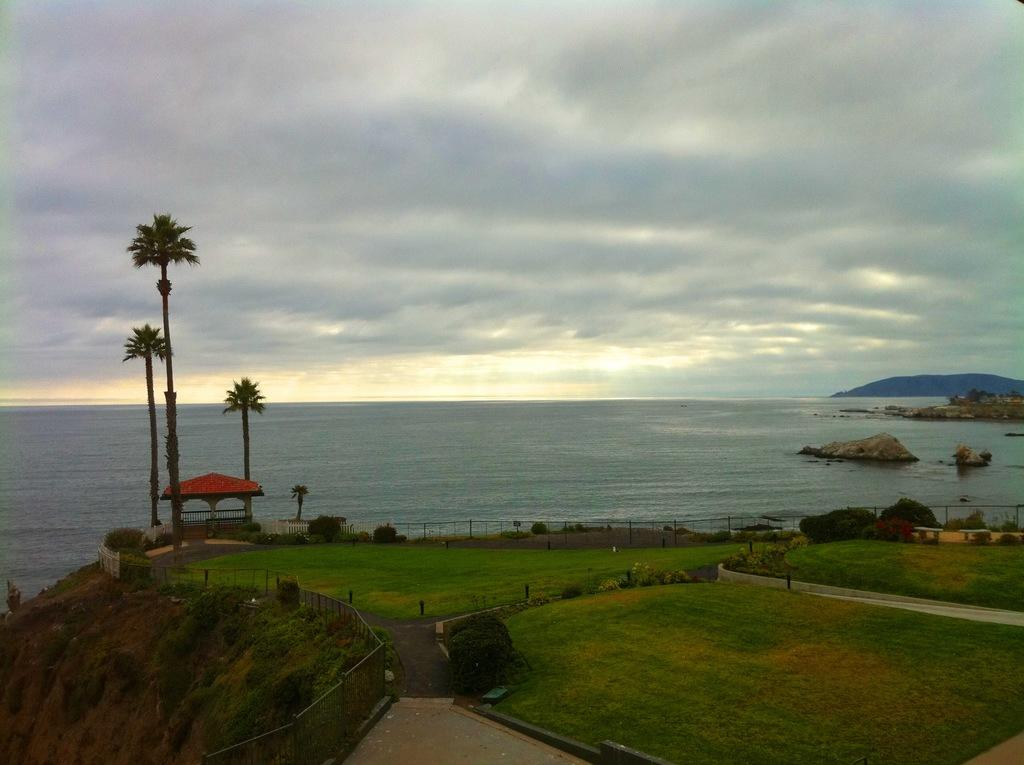What type of vegetation can be seen in the image? There is grass, a plant, and trees visible in the image. What natural landmark is present in the image? There is a mountain in the image. What body of water is visible in the image? There is water visible in the image. What man-made structure can be seen in the image? There is a fence in the image. What type of path is present in the image? There is a footpath in the image. What type of rock formation is present in the image? There are big stones in the image. What type of shelter is present in the image? There is a tent in the image. What is the condition of the sky in the image? The sky is cloudy in the image. What invention is being demonstrated by the cannon in the image? There is no cannon present in the image, so no invention is being demonstrated. What advice does the brother give to the person in the image? There is no brother or person present in the image, so no advice can be given. 